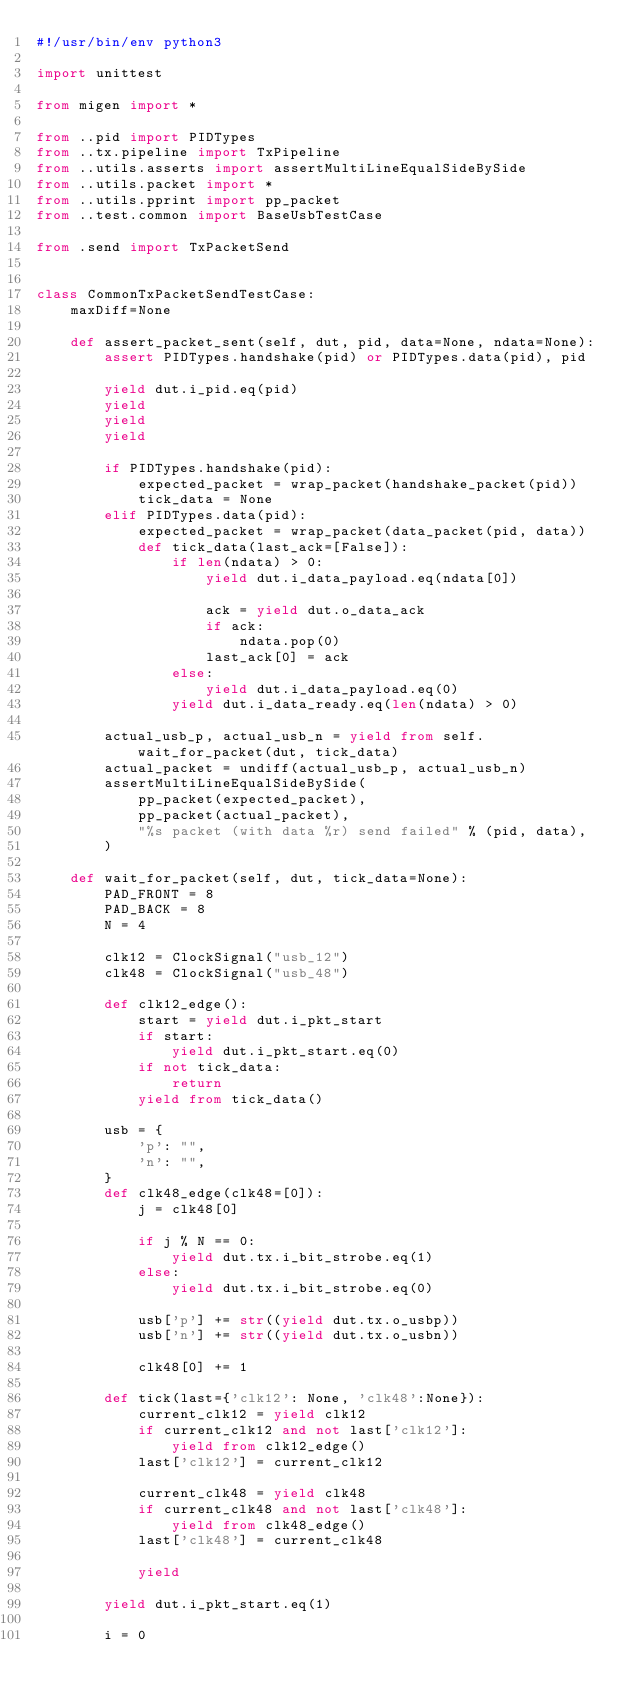Convert code to text. <code><loc_0><loc_0><loc_500><loc_500><_Python_>#!/usr/bin/env python3

import unittest

from migen import *

from ..pid import PIDTypes
from ..tx.pipeline import TxPipeline
from ..utils.asserts import assertMultiLineEqualSideBySide
from ..utils.packet import *
from ..utils.pprint import pp_packet
from ..test.common import BaseUsbTestCase

from .send import TxPacketSend


class CommonTxPacketSendTestCase:
    maxDiff=None

    def assert_packet_sent(self, dut, pid, data=None, ndata=None):
        assert PIDTypes.handshake(pid) or PIDTypes.data(pid), pid

        yield dut.i_pid.eq(pid)
        yield
        yield
        yield

        if PIDTypes.handshake(pid):
            expected_packet = wrap_packet(handshake_packet(pid))
            tick_data = None
        elif PIDTypes.data(pid):
            expected_packet = wrap_packet(data_packet(pid, data))
            def tick_data(last_ack=[False]):
                if len(ndata) > 0:
                    yield dut.i_data_payload.eq(ndata[0])

                    ack = yield dut.o_data_ack
                    if ack:
                        ndata.pop(0)
                    last_ack[0] = ack
                else:
                    yield dut.i_data_payload.eq(0)
                yield dut.i_data_ready.eq(len(ndata) > 0)

        actual_usb_p, actual_usb_n = yield from self.wait_for_packet(dut, tick_data)
        actual_packet = undiff(actual_usb_p, actual_usb_n)
        assertMultiLineEqualSideBySide(
            pp_packet(expected_packet),
            pp_packet(actual_packet),
            "%s packet (with data %r) send failed" % (pid, data),
        )

    def wait_for_packet(self, dut, tick_data=None):
        PAD_FRONT = 8
        PAD_BACK = 8
        N = 4

        clk12 = ClockSignal("usb_12")
        clk48 = ClockSignal("usb_48")

        def clk12_edge():
            start = yield dut.i_pkt_start
            if start:
                yield dut.i_pkt_start.eq(0)
            if not tick_data:
                return
            yield from tick_data()

        usb = {
            'p': "",
            'n': "",
        }
        def clk48_edge(clk48=[0]):
            j = clk48[0]

            if j % N == 0:
                yield dut.tx.i_bit_strobe.eq(1)
            else:
                yield dut.tx.i_bit_strobe.eq(0)

            usb['p'] += str((yield dut.tx.o_usbp))
            usb['n'] += str((yield dut.tx.o_usbn))

            clk48[0] += 1

        def tick(last={'clk12': None, 'clk48':None}):
            current_clk12 = yield clk12
            if current_clk12 and not last['clk12']:
                yield from clk12_edge()
            last['clk12'] = current_clk12

            current_clk48 = yield clk48
            if current_clk48 and not last['clk48']:
                yield from clk48_edge()
            last['clk48'] = current_clk48

            yield

        yield dut.i_pkt_start.eq(1)

        i = 0</code> 